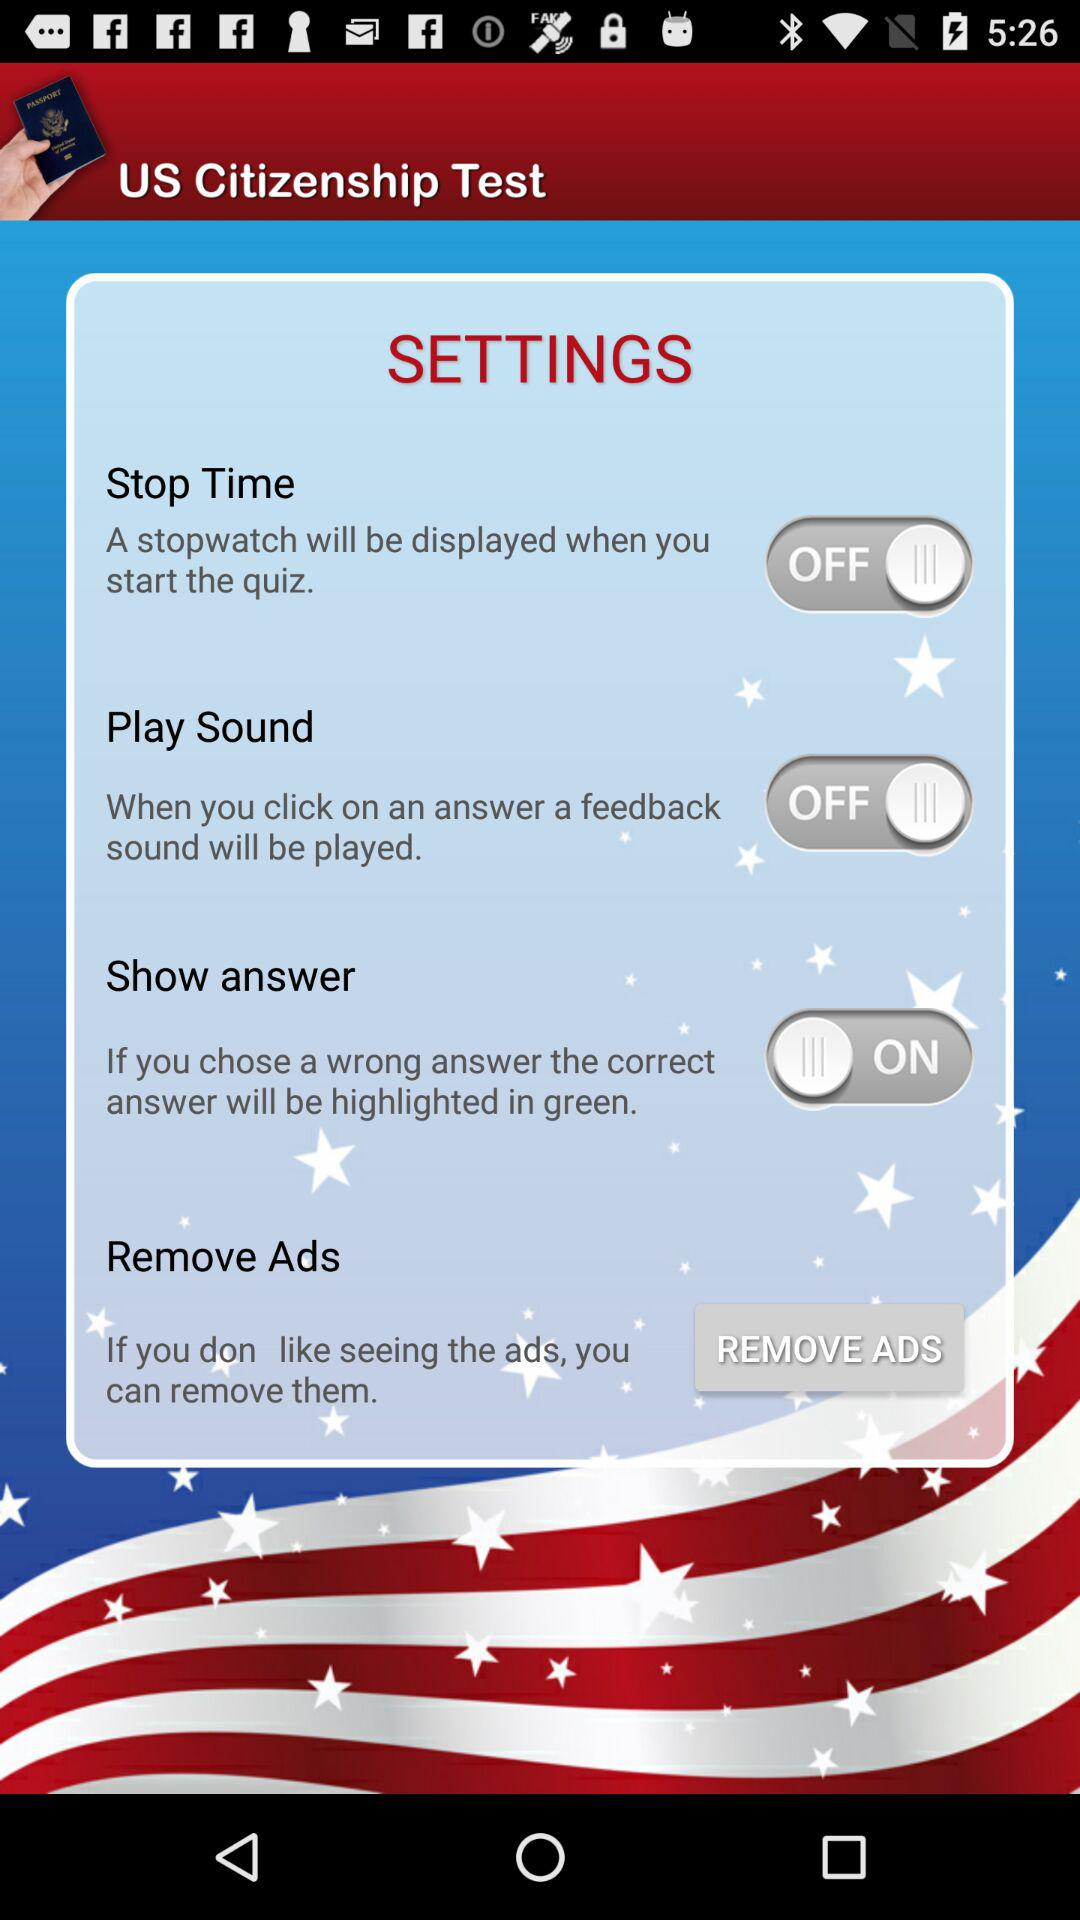Is "Stop Time" alert turned on or off? "Stop Time" alert is "off". 